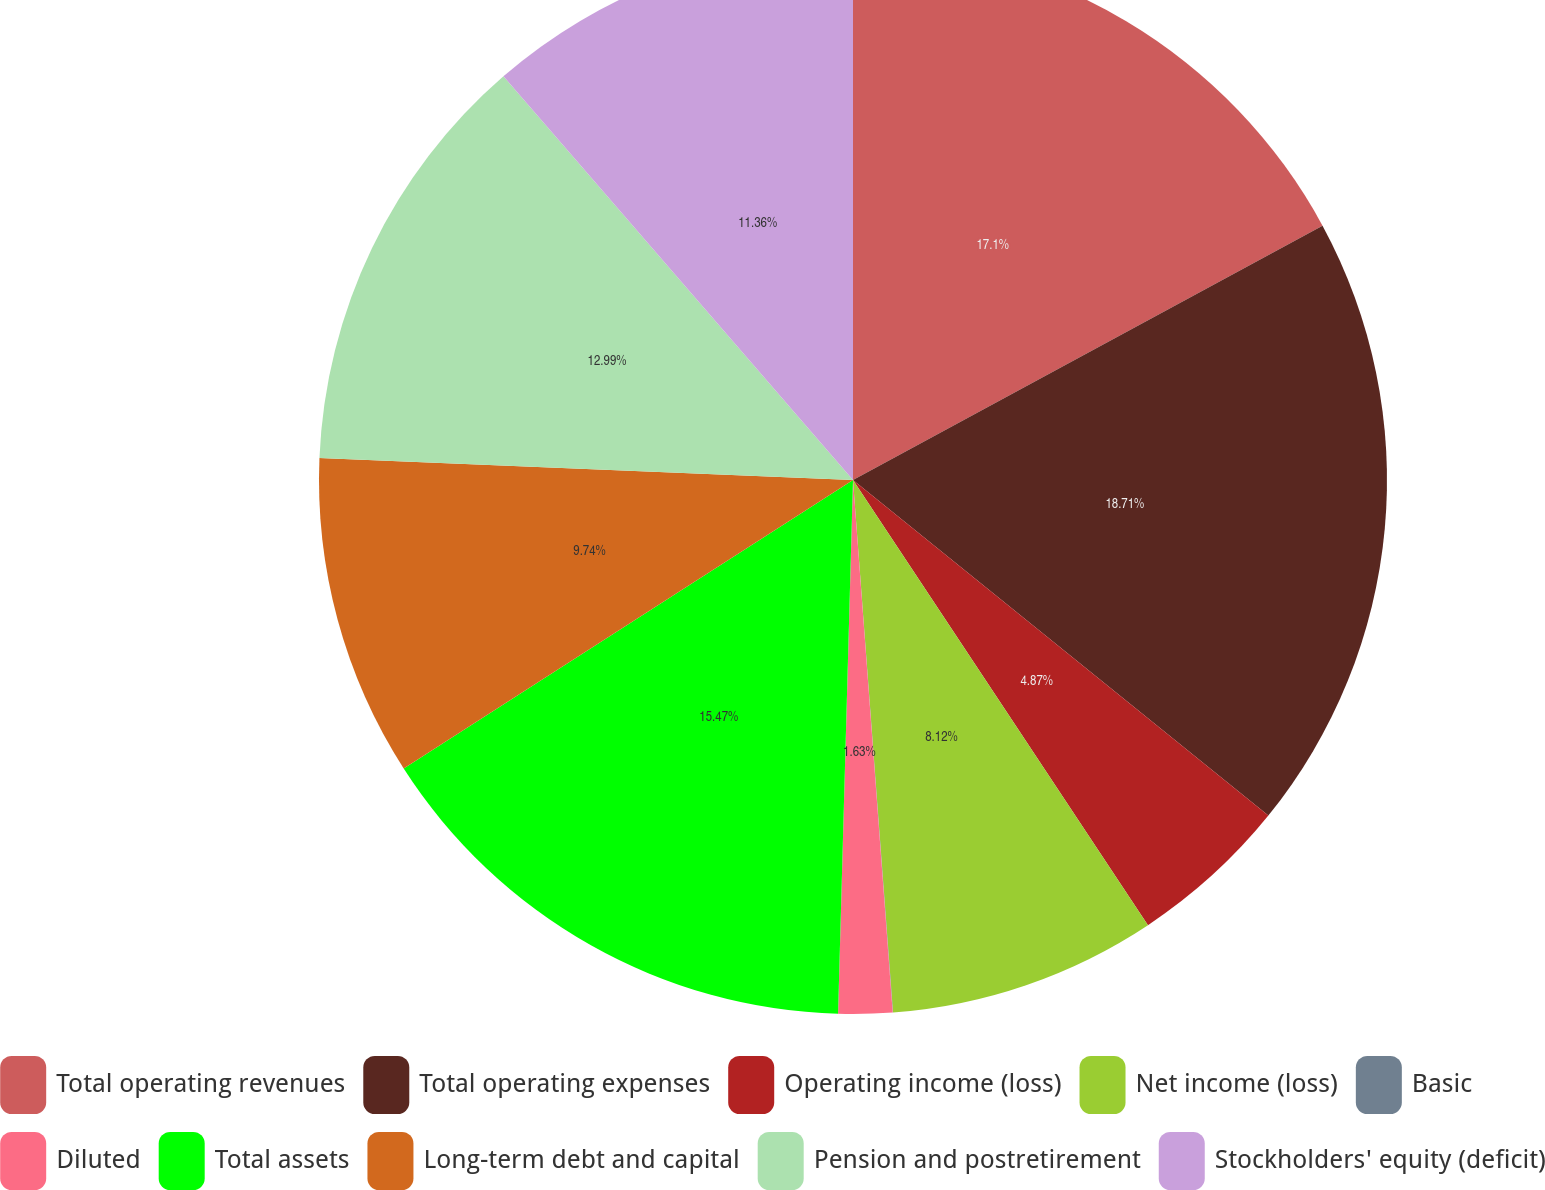<chart> <loc_0><loc_0><loc_500><loc_500><pie_chart><fcel>Total operating revenues<fcel>Total operating expenses<fcel>Operating income (loss)<fcel>Net income (loss)<fcel>Basic<fcel>Diluted<fcel>Total assets<fcel>Long-term debt and capital<fcel>Pension and postretirement<fcel>Stockholders' equity (deficit)<nl><fcel>17.1%<fcel>18.72%<fcel>4.87%<fcel>8.12%<fcel>0.01%<fcel>1.63%<fcel>15.47%<fcel>9.74%<fcel>12.99%<fcel>11.36%<nl></chart> 